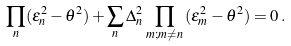<formula> <loc_0><loc_0><loc_500><loc_500>\, \prod _ { n } ( \epsilon _ { n } ^ { 2 } - \theta ^ { 2 } ) + \sum _ { n } \Delta _ { n } ^ { 2 } \, \prod _ { m ; m \neq n } \, ( \epsilon _ { m } ^ { 2 } - \theta ^ { 2 } ) = 0 \, .</formula> 